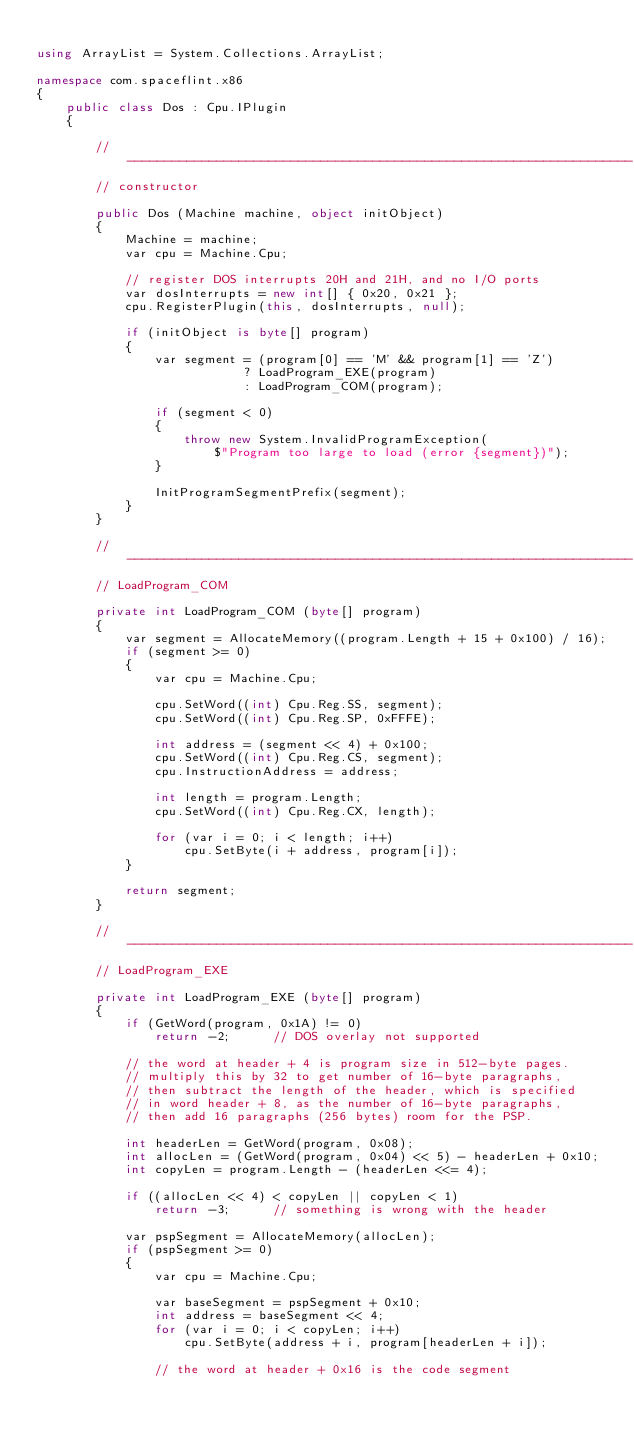Convert code to text. <code><loc_0><loc_0><loc_500><loc_500><_C#_>
using ArrayList = System.Collections.ArrayList;

namespace com.spaceflint.x86
{
    public class Dos : Cpu.IPlugin
    {

        // --------------------------------------------------------------------
        // constructor

        public Dos (Machine machine, object initObject)
        {
            Machine = machine;
            var cpu = Machine.Cpu;

            // register DOS interrupts 20H and 21H, and no I/O ports
            var dosInterrupts = new int[] { 0x20, 0x21 };
            cpu.RegisterPlugin(this, dosInterrupts, null);

            if (initObject is byte[] program)
            {
                var segment = (program[0] == 'M' && program[1] == 'Z')
                            ? LoadProgram_EXE(program)
                            : LoadProgram_COM(program);

                if (segment < 0)
                {
                    throw new System.InvalidProgramException(
                        $"Program too large to load (error {segment})");
                }

                InitProgramSegmentPrefix(segment);
            }
        }

        // --------------------------------------------------------------------
        // LoadProgram_COM

        private int LoadProgram_COM (byte[] program)
        {
            var segment = AllocateMemory((program.Length + 15 + 0x100) / 16);
            if (segment >= 0)
            {
                var cpu = Machine.Cpu;

                cpu.SetWord((int) Cpu.Reg.SS, segment);
                cpu.SetWord((int) Cpu.Reg.SP, 0xFFFE);

                int address = (segment << 4) + 0x100;
                cpu.SetWord((int) Cpu.Reg.CS, segment);
                cpu.InstructionAddress = address;

                int length = program.Length;
                cpu.SetWord((int) Cpu.Reg.CX, length);

                for (var i = 0; i < length; i++)
                    cpu.SetByte(i + address, program[i]);
            }

            return segment;
        }

        // --------------------------------------------------------------------
        // LoadProgram_EXE

        private int LoadProgram_EXE (byte[] program)
        {
            if (GetWord(program, 0x1A) != 0)
                return -2;      // DOS overlay not supported

            // the word at header + 4 is program size in 512-byte pages.
            // multiply this by 32 to get number of 16-byte paragraphs,
            // then subtract the length of the header, which is specified
            // in word header + 8, as the number of 16-byte paragraphs,
            // then add 16 paragraphs (256 bytes) room for the PSP.

            int headerLen = GetWord(program, 0x08);
            int allocLen = (GetWord(program, 0x04) << 5) - headerLen + 0x10;
            int copyLen = program.Length - (headerLen <<= 4);

            if ((allocLen << 4) < copyLen || copyLen < 1)
                return -3;      // something is wrong with the header

            var pspSegment = AllocateMemory(allocLen);
            if (pspSegment >= 0)
            {
                var cpu = Machine.Cpu;

                var baseSegment = pspSegment + 0x10;
                int address = baseSegment << 4;
                for (var i = 0; i < copyLen; i++)
                    cpu.SetByte(address + i, program[headerLen + i]);

                // the word at header + 0x16 is the code segment</code> 